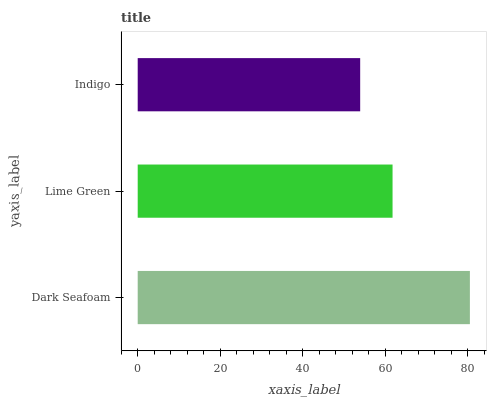Is Indigo the minimum?
Answer yes or no. Yes. Is Dark Seafoam the maximum?
Answer yes or no. Yes. Is Lime Green the minimum?
Answer yes or no. No. Is Lime Green the maximum?
Answer yes or no. No. Is Dark Seafoam greater than Lime Green?
Answer yes or no. Yes. Is Lime Green less than Dark Seafoam?
Answer yes or no. Yes. Is Lime Green greater than Dark Seafoam?
Answer yes or no. No. Is Dark Seafoam less than Lime Green?
Answer yes or no. No. Is Lime Green the high median?
Answer yes or no. Yes. Is Lime Green the low median?
Answer yes or no. Yes. Is Dark Seafoam the high median?
Answer yes or no. No. Is Dark Seafoam the low median?
Answer yes or no. No. 